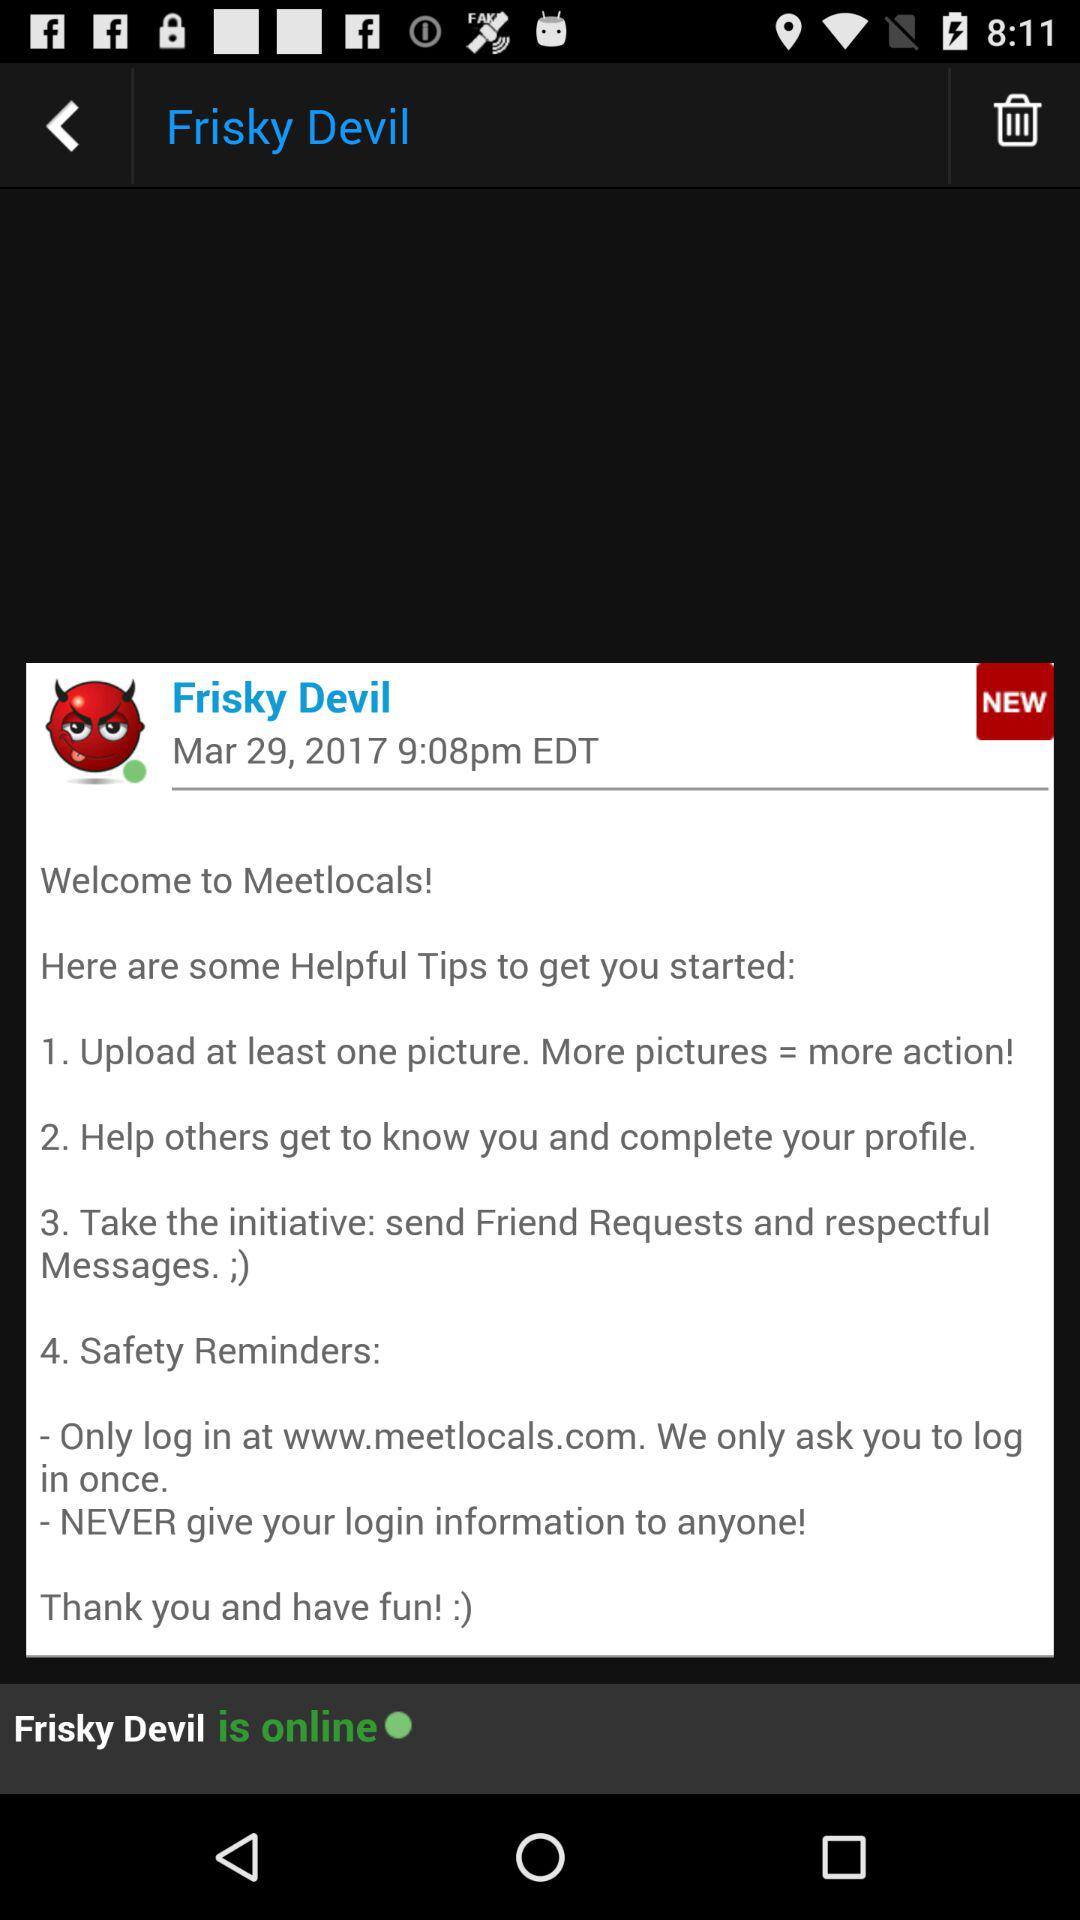What is the time? The time is 9:08 p.m. 